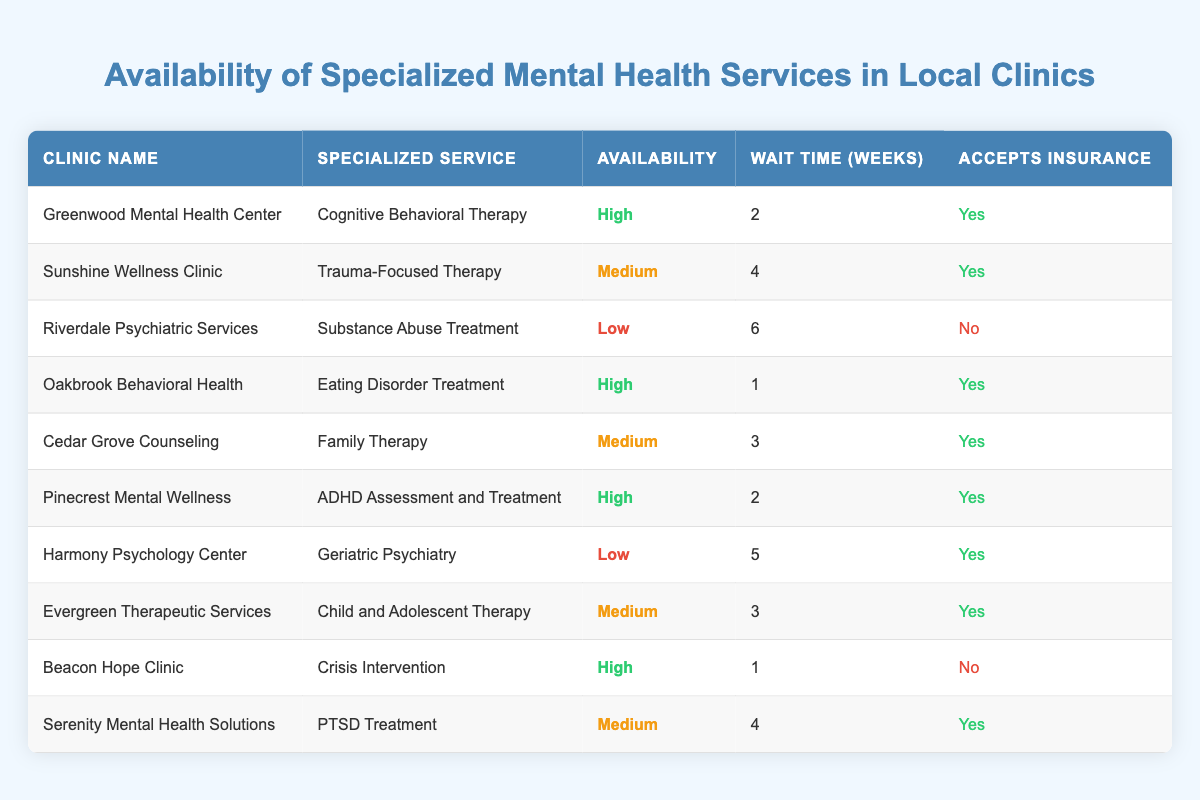What is the availability of Eating Disorder Treatment at Oakbrook Behavioral Health? The table lists Oakbrook Behavioral Health under "Clinic Name" with the corresponding specialized service of "Eating Disorder Treatment," which has an availability rating of "High."
Answer: High How long is the wait time for Trauma-Focused Therapy at Sunshine Wellness Clinic? Sunshine Wellness Clinic is shown in the table with "Trauma-Focused Therapy," and the wait time listed is 4 weeks.
Answer: 4 weeks Which clinics accept insurance for high availability services? The table shows the clinics with high availability services are Greenwood Mental Health Center, Oakbrook Behavioral Health, Pinecrest Mental Wellness, and Beacon Hope Clinic. Out of these, only Greenwood Mental Health Center, Oakbrook Behavioral Health, and Pinecrest Mental Wellness accept insurance (marked "Yes").
Answer: Greenwood Mental Health Center, Oakbrook Behavioral Health, Pinecrest Mental Wellness Is the wait time longer for Substance Abuse Treatment than for Geriatric Psychiatry? The wait time for Substance Abuse Treatment at Riverdale Psychiatric Services is listed as 6 weeks, while the wait time for Geriatric Psychiatry at Harmony Psychology Center is 5 weeks. Since 6 weeks is greater than 5 weeks, the wait time for Substance Abuse Treatment is indeed longer.
Answer: Yes What's the average wait time for clinics that do not accept insurance? The clinics listed with "No" for accepting insurance are Riverdale Psychiatric Services (6 weeks) and Beacon Hope Clinic (1 week). The average wait time is calculated as (6 + 1) / 2 = 3.5 weeks.
Answer: 3.5 weeks How many clinics offer Child and Adolescent Therapy with medium availability? The table lists Evergreen Therapeutic Services as the only clinic providing Child and Adolescent Therapy, which has a medium availability rating.
Answer: 1 What percentage of clinics have high availability? There are 10 clinics in total, and 4 of them (Greenwood Mental Health Center, Oakbrook Behavioral Health, Pinecrest Mental Wellness, Beacon Hope Clinic) are marked with high availability. To find the percentage, the calculation is (4/10) * 100 = 40%.
Answer: 40% Are there any clinics that have a wait time of 1 week? The table shows that both Oakbrook Behavioral Health (Eating Disorder Treatment) and Beacon Hope Clinic (Crisis Intervention) have a wait time of 1 week. Therefore, there are clinics with a wait time of 1 week.
Answer: Yes 